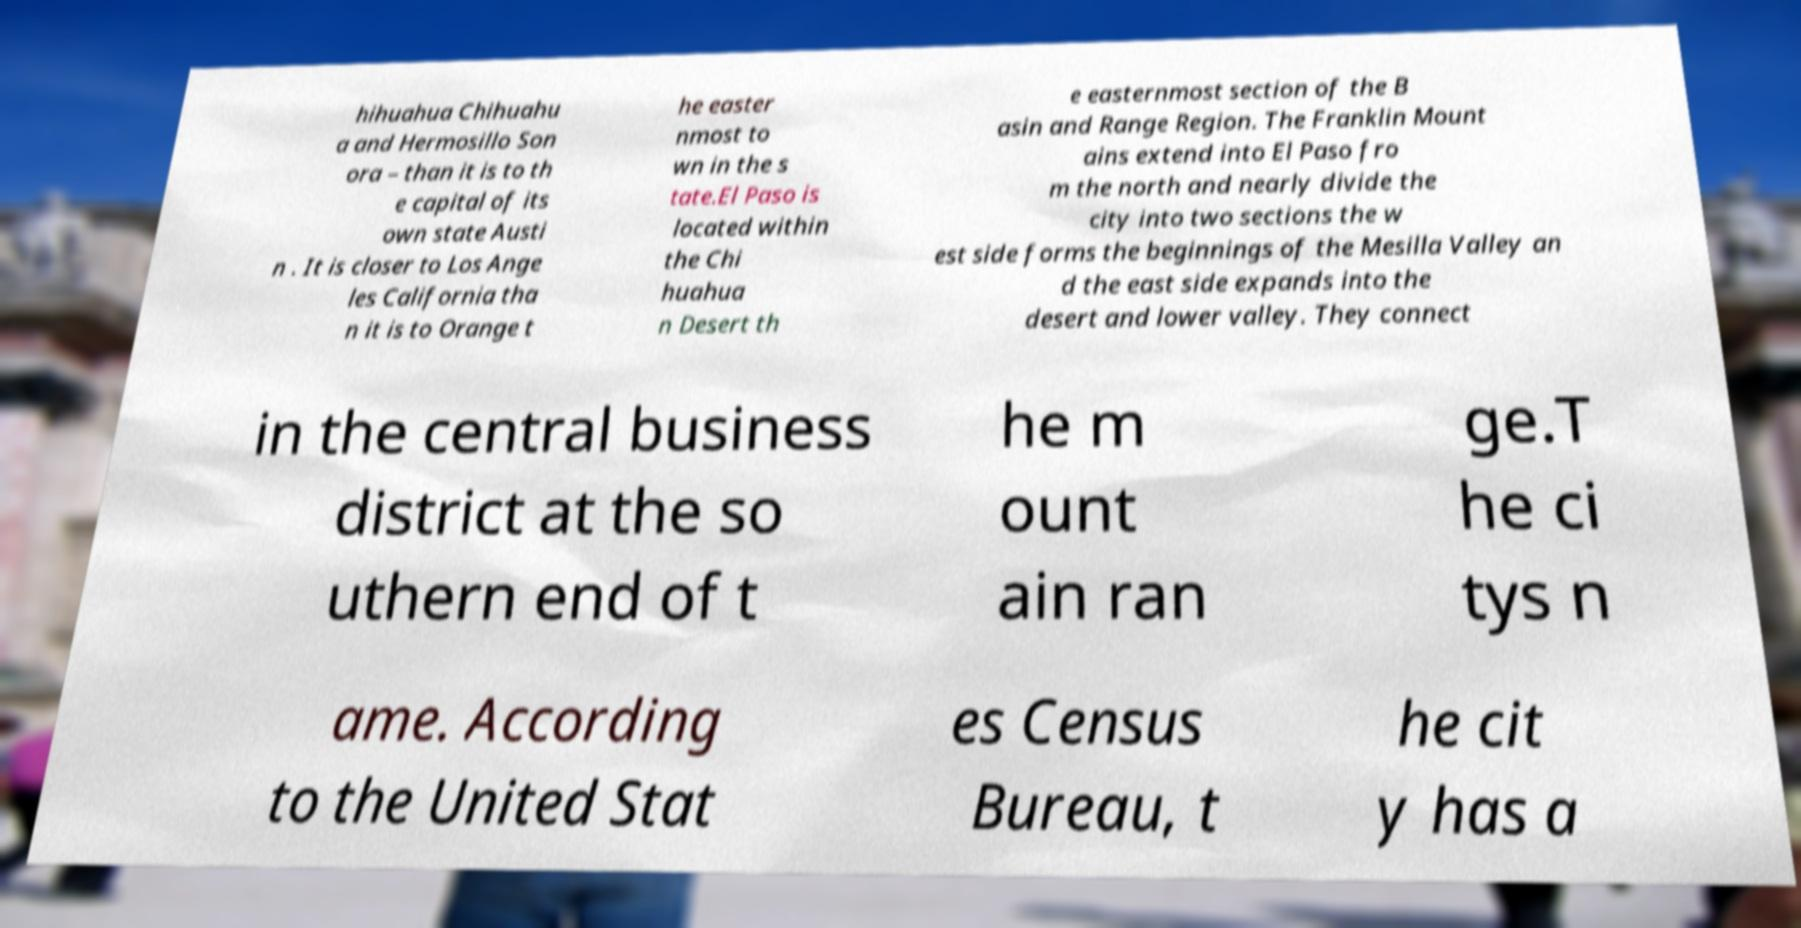I need the written content from this picture converted into text. Can you do that? hihuahua Chihuahu a and Hermosillo Son ora – than it is to th e capital of its own state Austi n . It is closer to Los Ange les California tha n it is to Orange t he easter nmost to wn in the s tate.El Paso is located within the Chi huahua n Desert th e easternmost section of the B asin and Range Region. The Franklin Mount ains extend into El Paso fro m the north and nearly divide the city into two sections the w est side forms the beginnings of the Mesilla Valley an d the east side expands into the desert and lower valley. They connect in the central business district at the so uthern end of t he m ount ain ran ge.T he ci tys n ame. According to the United Stat es Census Bureau, t he cit y has a 